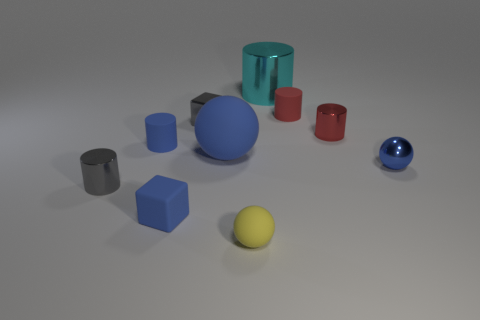What can you say about the lighting and mood of the scene? The lighting in the image appears to be soft and diffused, likely coming from above, as indicated by the gentle shadows under each object. There's no harsh light or stark contrasts. The mood evoked by this setting is calm and neutral, with a gentle emphasis on the objects' colors and shapes due to the soft lighting, which creates a subtle and tranquil atmosphere. 